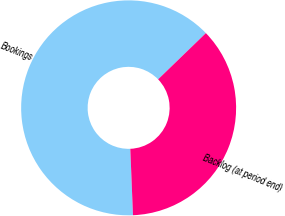<chart> <loc_0><loc_0><loc_500><loc_500><pie_chart><fcel>Bookings<fcel>Backlog (at period end)<nl><fcel>63.41%<fcel>36.59%<nl></chart> 